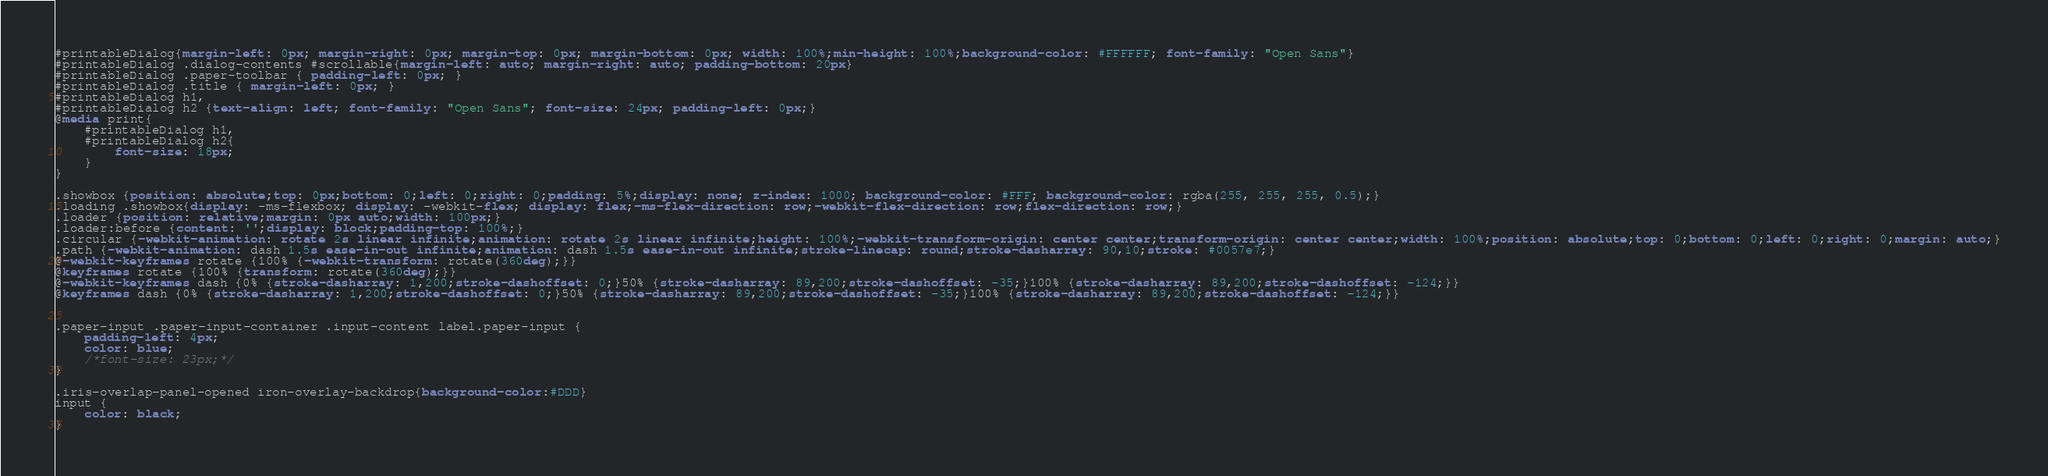<code> <loc_0><loc_0><loc_500><loc_500><_CSS_>#printableDialog{margin-left: 0px; margin-right: 0px; margin-top: 0px; margin-bottom: 0px; width: 100%;min-height: 100%;background-color: #FFFFFF; font-family: "Open Sans"}
#printableDialog .dialog-contents #scrollable{margin-left: auto; margin-right: auto; padding-bottom: 20px}
#printableDialog .paper-toolbar { padding-left: 0px; }
#printableDialog .title { margin-left: 0px; }
#printableDialog h1,
#printableDialog h2 {text-align: left; font-family: "Open Sans"; font-size: 24px; padding-left: 0px;}
@media print{
    #printableDialog h1,
    #printableDialog h2{
        font-size: 18px;
    }
}

.showbox {position: absolute;top: 0px;bottom: 0;left: 0;right: 0;padding: 5%;display: none; z-index: 1000; background-color: #FFF; background-color: rgba(255, 255, 255, 0.5);}
.loading .showbox{display: -ms-flexbox; display: -webkit-flex; display: flex;-ms-flex-direction: row;-webkit-flex-direction: row;flex-direction: row;}
.loader {position: relative;margin: 0px auto;width: 100px;}
.loader:before {content: '';display: block;padding-top: 100%;}
.circular {-webkit-animation: rotate 2s linear infinite;animation: rotate 2s linear infinite;height: 100%;-webkit-transform-origin: center center;transform-origin: center center;width: 100%;position: absolute;top: 0;bottom: 0;left: 0;right: 0;margin: auto;}
.path {-webkit-animation: dash 1.5s ease-in-out infinite;animation: dash 1.5s ease-in-out infinite;stroke-linecap: round;stroke-dasharray: 90,10;stroke: #0057e7;}
@-webkit-keyframes rotate {100% {-webkit-transform: rotate(360deg);}}
@keyframes rotate {100% {transform: rotate(360deg);}}
@-webkit-keyframes dash {0% {stroke-dasharray: 1,200;stroke-dashoffset: 0;}50% {stroke-dasharray: 89,200;stroke-dashoffset: -35;}100% {stroke-dasharray: 89,200;stroke-dashoffset: -124;}}
@keyframes dash {0% {stroke-dasharray: 1,200;stroke-dashoffset: 0;}50% {stroke-dasharray: 89,200;stroke-dashoffset: -35;}100% {stroke-dasharray: 89,200;stroke-dashoffset: -124;}}


.paper-input .paper-input-container .input-content label.paper-input {
	padding-left: 4px;
	color: blue;
	/*font-size: 23px;*/
}

.iris-overlap-panel-opened iron-overlay-backdrop{background-color:#DDD}
input {
	color: black;
}


</code> 